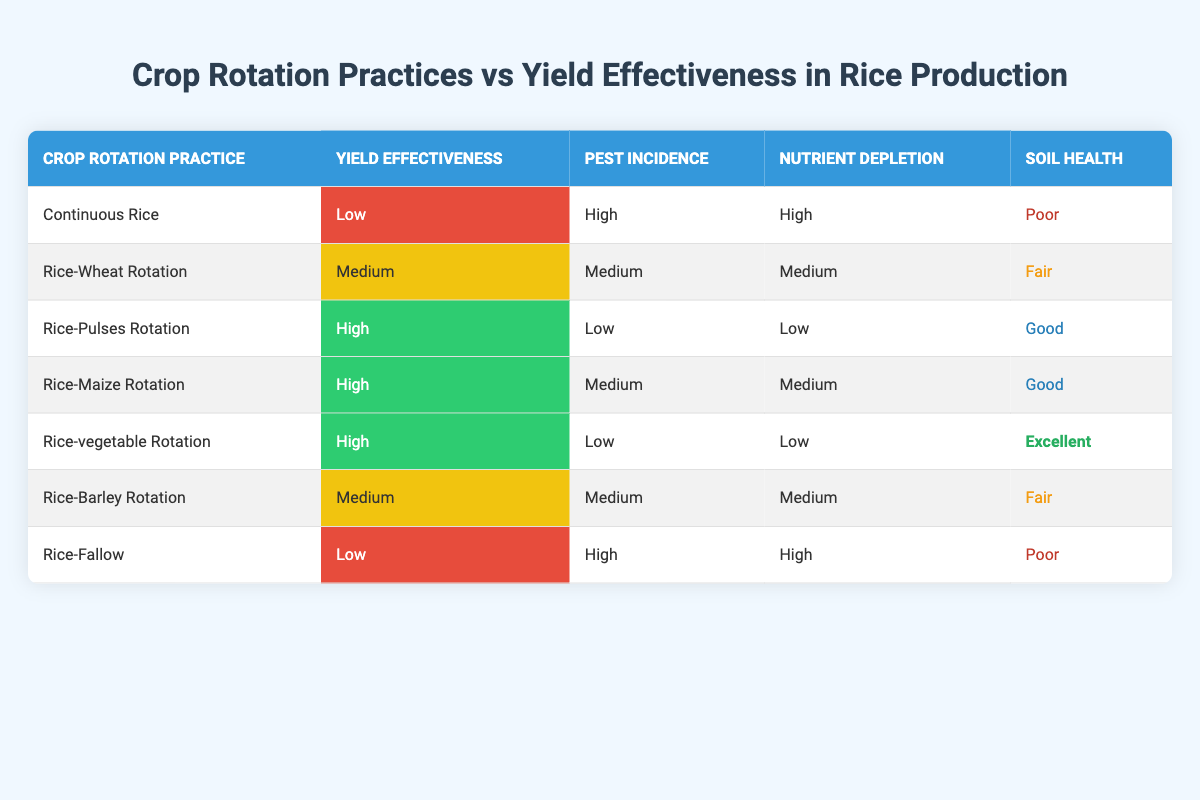What is the yield effectiveness of Continuous Rice? Looking at the row for Continuous Rice, the yield effectiveness is stated as "Low." Thus, we get the exact value from the table directly.
Answer: Low Which crop rotation practice has the highest soil health rating? In the table, the soil health ratings are classified as Poor, Fair, Good, and Excellent. The Rice-vegetable Rotation has the rating "Excellent," which is the highest among all practices listed.
Answer: Rice-vegetable Rotation How many crop rotation practices have a yield effectiveness classified as Medium? We can count the practices with "Medium" yield effectiveness by examining the relevant column. These practices are Rice-Wheat Rotation, Rice-Barley Rotation, totaling 2.
Answer: 2 Is the pest incidence low for Rice-Pulses Rotation? The specific row for Rice-Pulses Rotation indicates a pest incidence of "Low." Therefore, this statement is true based on the table data.
Answer: Yes What is the average nutrient depletion rating for all crop rotation practices? The nutrient depletion ratings given in the table are High, Medium, Low, and Medium. To represent these quantitatively, we can assign values (High = 3, Medium = 2, Low = 1). Converting the ratings results in (3 + 2 + 1 + 2) / 7 = 1.71, which is approximately 2, leading to an average of Medium when expressed in the original terms.
Answer: Medium Which crop rotation practice has the lowest pest incidence? By checking the pest incidence column, Rice-Pulses Rotation and Rice-vegetable Rotation show "Low," but Rice-Pulses Rotation only has a low pest incidence without any qualifiers. Thus, it has the lowest incidence.
Answer: Rice-Pulses Rotation Are there more practices with High yield effectiveness than Low? Counting the yields, there are 3 practices classified as High (Rice-Pulses, Rice-Maize, Rice-vegetable) and 2 classified as Low (Continuous Rice, Rice-Fallow). Since 3 is greater than 2, the answer is affirmatively yes.
Answer: Yes What is the difference in soil health ratings between Rice-Wheat Rotation and Rice-vegetable Rotation? The soil health rating for Rice-Wheat Rotation is "Fair" and "Excellent" for Rice-vegetable Rotation. In a qualitative view, Fair is a lower rating than Excellent. Therefore, the difference is significant, meaning Rice-vegetable has considerably better soil health than Rice-Wheat.
Answer: Fair vs. Excellent (significant difference) 